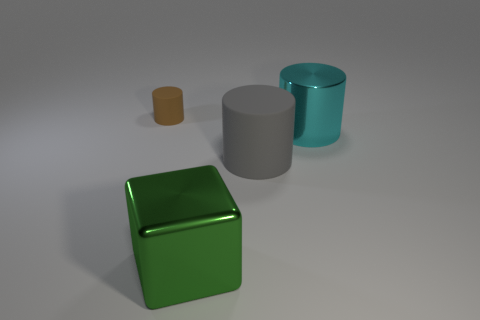Are there any other things that are the same size as the brown cylinder?
Provide a short and direct response. No. What color is the other small object that is the same shape as the cyan metallic thing?
Make the answer very short. Brown. There is a cylinder that is both on the left side of the big shiny cylinder and in front of the small brown matte cylinder; what is its material?
Give a very brief answer. Rubber. Are the big thing that is in front of the big rubber object and the cyan object that is behind the large gray rubber object made of the same material?
Provide a short and direct response. Yes. The green metallic object is what size?
Provide a short and direct response. Large. There is another matte object that is the same shape as the gray matte thing; what is its size?
Offer a terse response. Small. What number of shiny things are to the left of the big shiny cylinder?
Offer a terse response. 1. There is a matte object behind the metal object on the right side of the big gray object; what color is it?
Provide a short and direct response. Brown. Is there anything else that has the same shape as the green object?
Offer a terse response. No. Are there the same number of shiny blocks behind the gray cylinder and small cylinders that are on the right side of the cyan shiny cylinder?
Provide a short and direct response. Yes. 